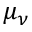<formula> <loc_0><loc_0><loc_500><loc_500>\mu _ { \nu }</formula> 